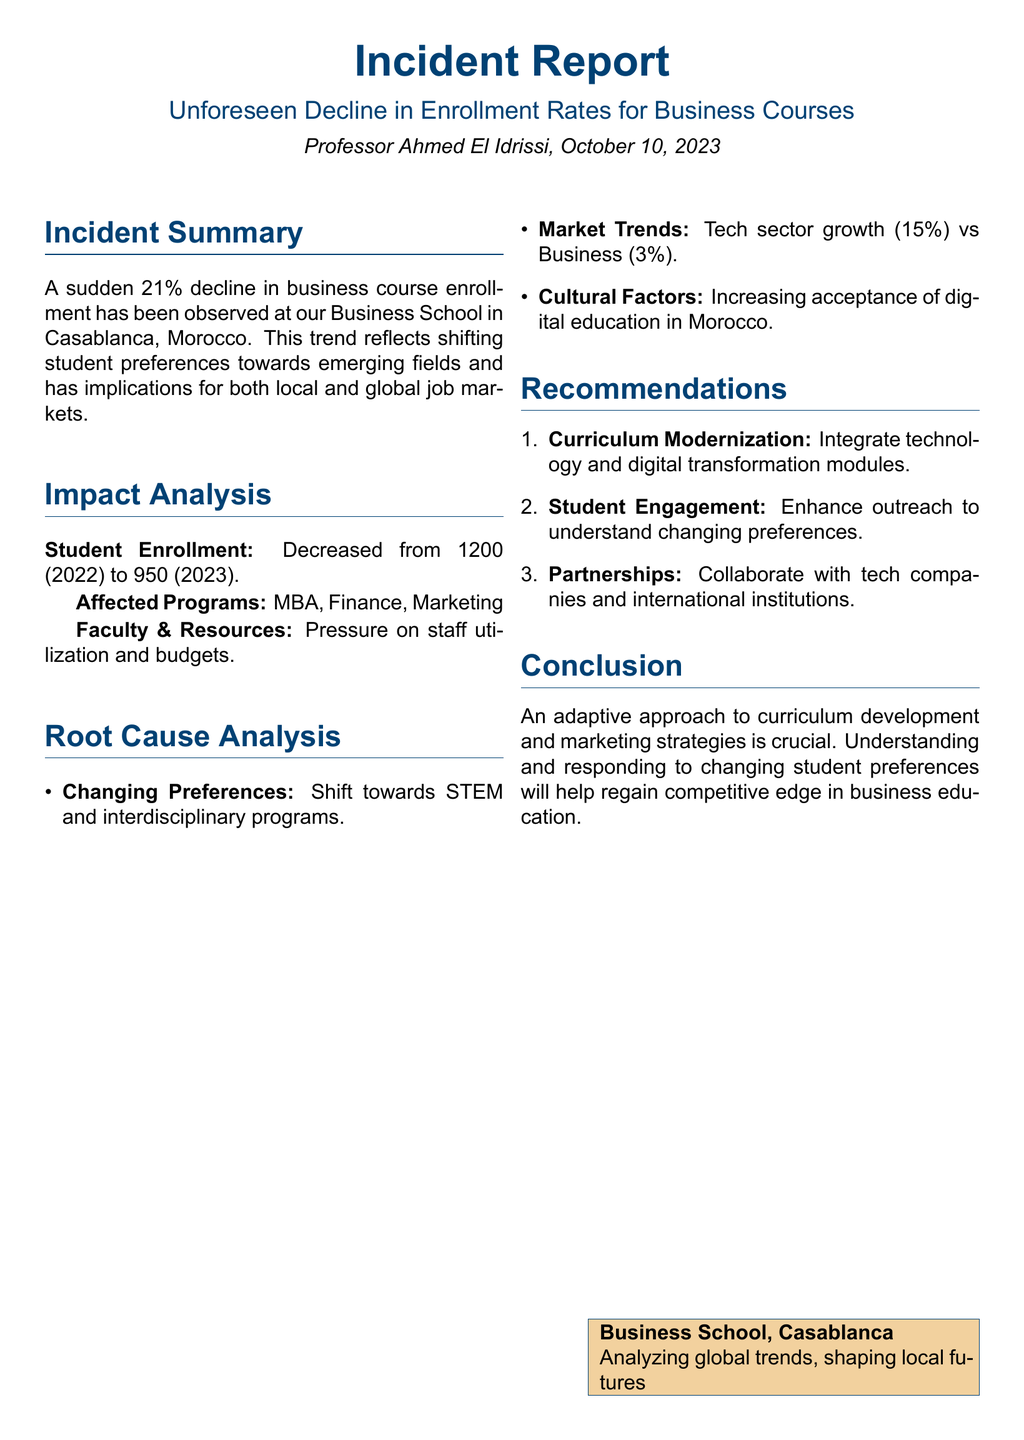what percentage decline in enrollment was observed? The incident report states there was a sudden 21% decline in business course enrollment.
Answer: 21% how many students were enrolled in 2022? The document indicates that the enrollment decreased from 1200 (2022) to 950 (2023).
Answer: 1200 what were the affected programs mentioned? The report lists the affected programs as MBA, Finance, and Marketing.
Answer: MBA, Finance, Marketing what is the growth percentage of the tech sector mentioned? According to the report, the tech sector growth is stated as 15%.
Answer: 15% what is one of the recommendations for curriculum improvement? The report recommends integrating technology and digital transformation modules.
Answer: Integrate technology and digital transformation modules what urgent issue is highlighted in the Impact Analysis section? The analysis mentions pressure on staff utilization and budgets due to the decline in enrollment.
Answer: Pressure on staff utilization and budgets what cultural factor is influencing student preferences? The report notes the increasing acceptance of digital education in Morocco as a cultural factor.
Answer: Increasing acceptance of digital education who authored the incident report? The report indicates that it was authored by Professor Ahmed El Idrissi.
Answer: Professor Ahmed El Idrissi what type of educational programs are students shifting towards? The document mentions a shift towards STEM and interdisciplinary programs.
Answer: STEM and interdisciplinary programs 